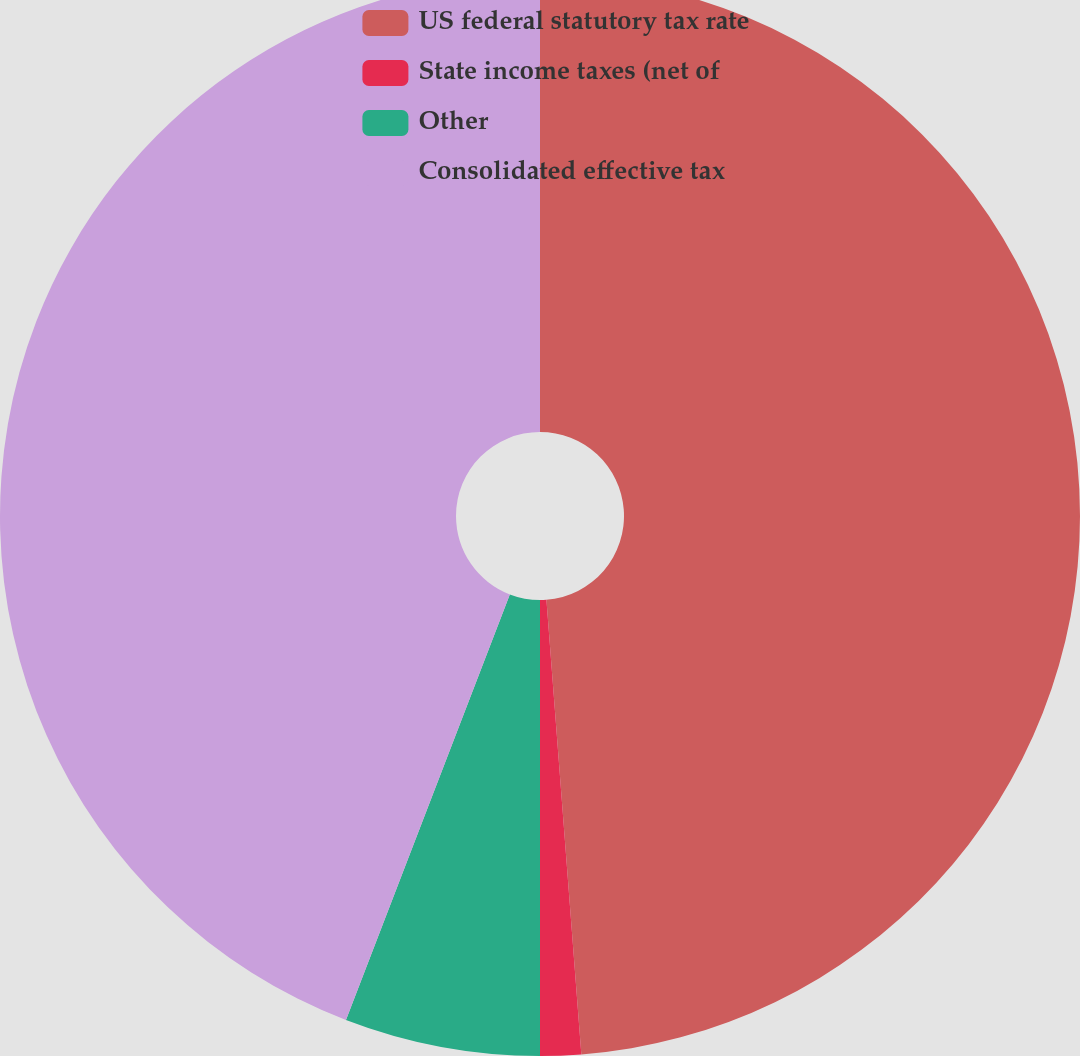Convert chart. <chart><loc_0><loc_0><loc_500><loc_500><pie_chart><fcel>US federal statutory tax rate<fcel>State income taxes (net of<fcel>Other<fcel>Consolidated effective tax<nl><fcel>48.78%<fcel>1.22%<fcel>5.85%<fcel>44.15%<nl></chart> 